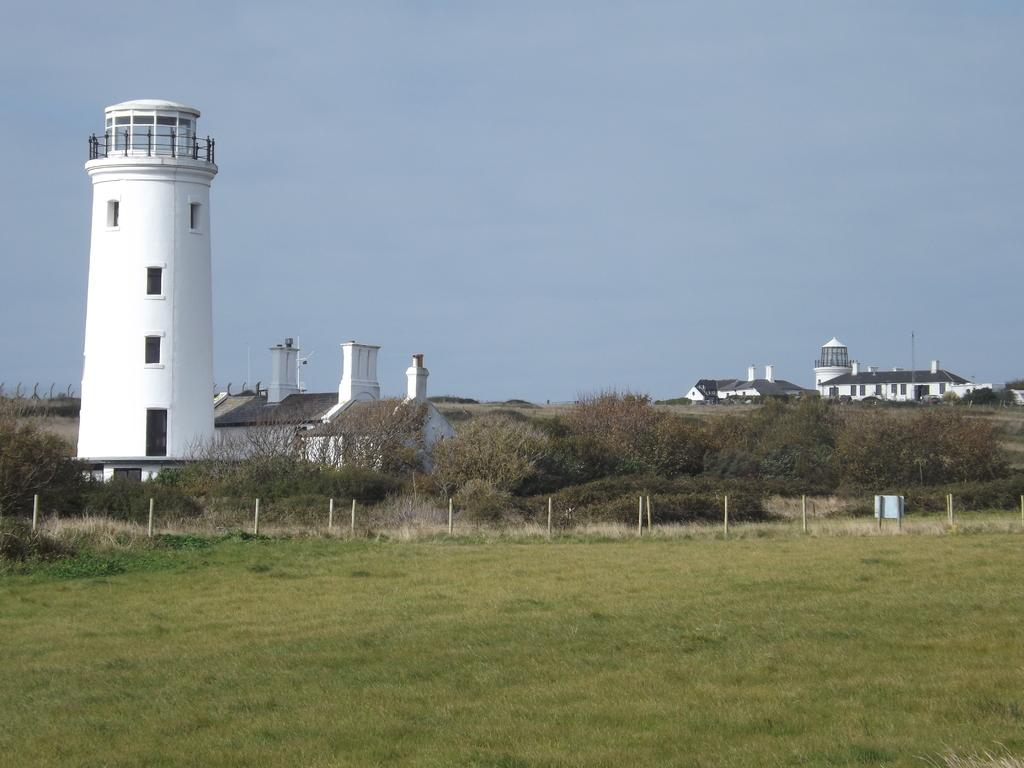What is the main structure in the image? There is a lighthouse in the image. What can be seen in the background of the image? There are many trees and buildings in the background of the image. What type of vegetation covers the ground in the image? The ground is covered with grass. What is visible at the top of the image? The sky is clear and visible at the top of the image. What type of cork can be seen on the lighthouse in the image? There is no cork present on the lighthouse in the image. What type of home is visible in the background of the image? The image does not show a home; it features a lighthouse, trees, and buildings in the background. 